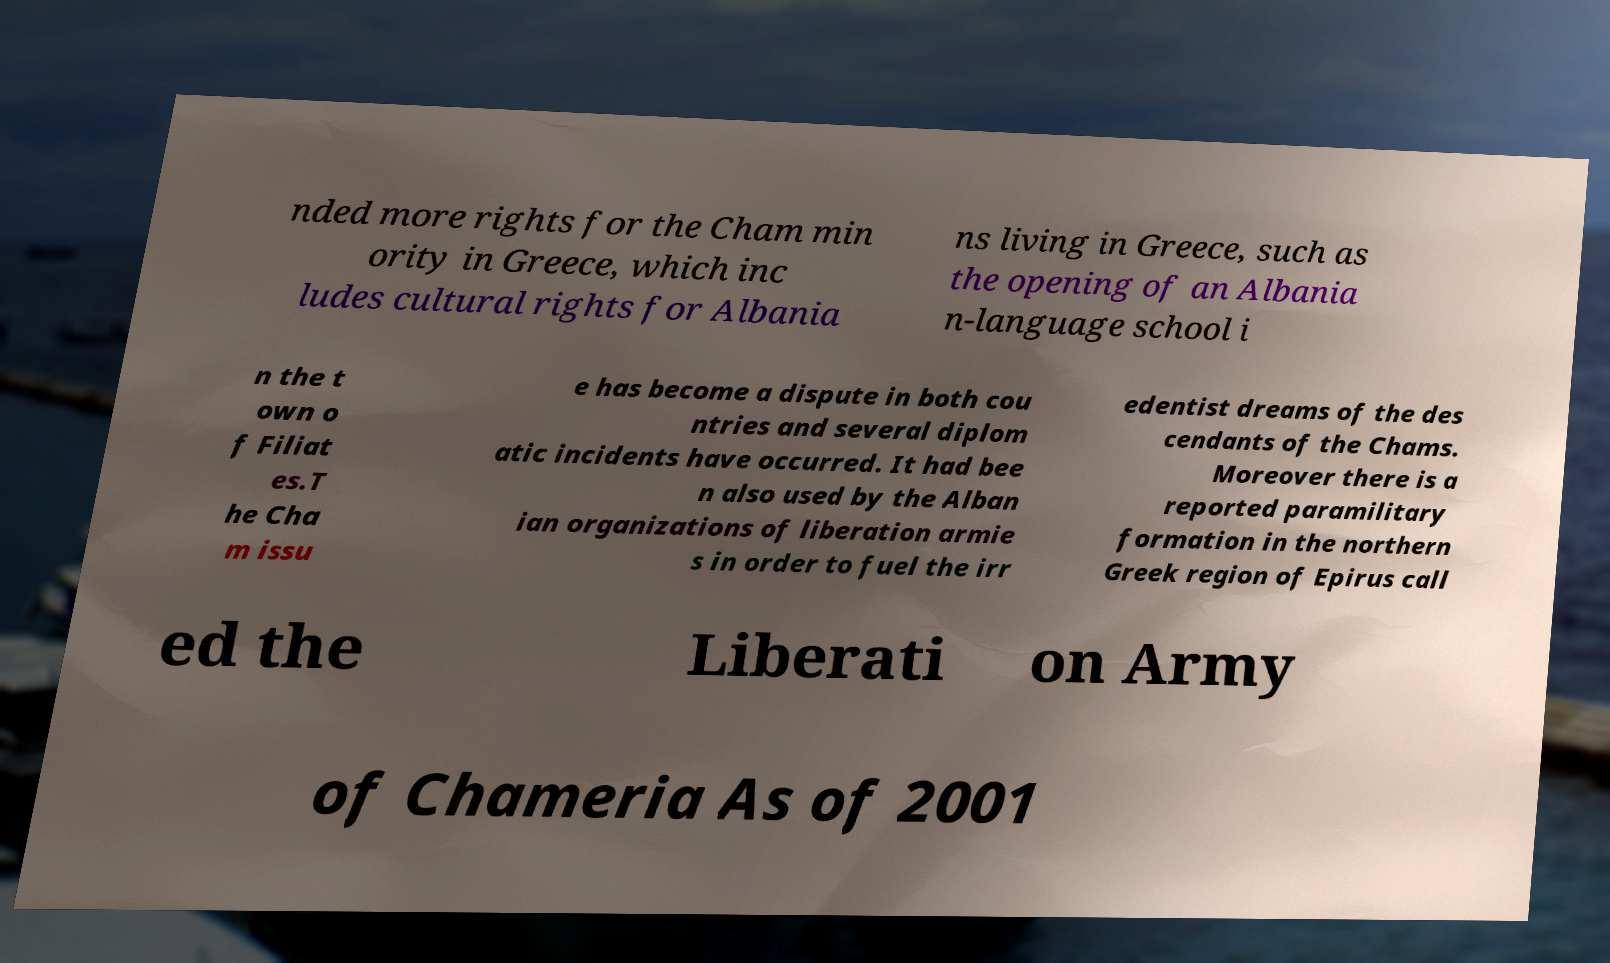Can you accurately transcribe the text from the provided image for me? nded more rights for the Cham min ority in Greece, which inc ludes cultural rights for Albania ns living in Greece, such as the opening of an Albania n-language school i n the t own o f Filiat es.T he Cha m issu e has become a dispute in both cou ntries and several diplom atic incidents have occurred. It had bee n also used by the Alban ian organizations of liberation armie s in order to fuel the irr edentist dreams of the des cendants of the Chams. Moreover there is a reported paramilitary formation in the northern Greek region of Epirus call ed the Liberati on Army of Chameria As of 2001 